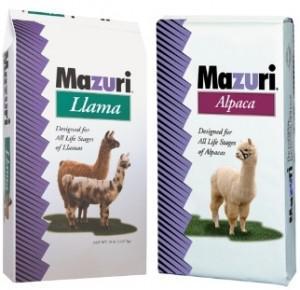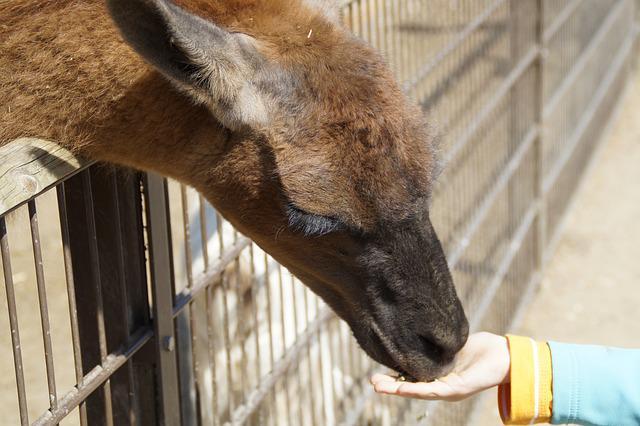The first image is the image on the left, the second image is the image on the right. Given the left and right images, does the statement "The left image contains one bag of food with two hooved animals on the front of the package, and the right image contains a mass of small bits of animal feed." hold true? Answer yes or no. No. The first image is the image on the left, the second image is the image on the right. Evaluate the accuracy of this statement regarding the images: "One image shows loose pet food pellets and another image shows a bag of animal food.". Is it true? Answer yes or no. No. 